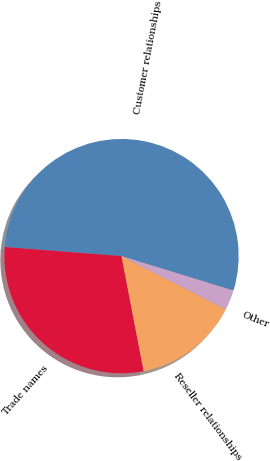Convert chart to OTSL. <chart><loc_0><loc_0><loc_500><loc_500><pie_chart><fcel>Customer relationships<fcel>Trade names<fcel>Reseller relationships<fcel>Other<nl><fcel>53.51%<fcel>29.27%<fcel>14.48%<fcel>2.74%<nl></chart> 